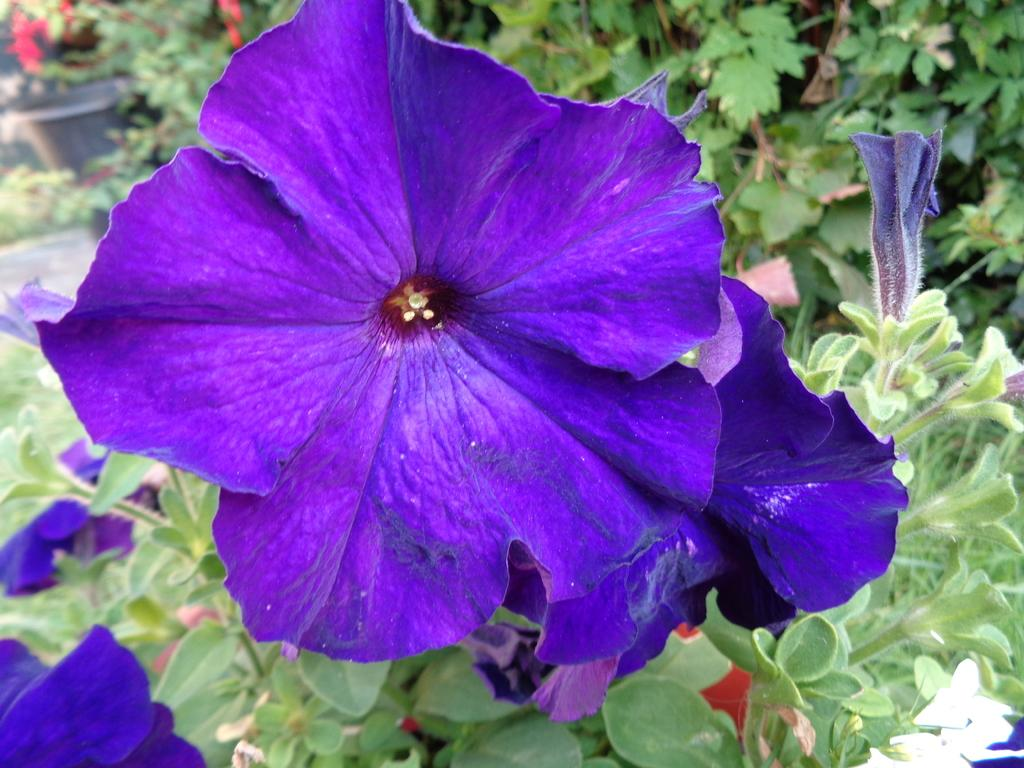What type of living organisms can be seen in the image? Flowers and plants can be seen in the image. Can you describe the plants in the image? The plants in the image are not specified, but they are present alongside the flowers. What type of bushes can be seen in the image? There is no mention of bushes in the image; only flowers and plants are mentioned. Is there a frame around the flowers in the image? There is no reference to a frame in the image; it only features flowers and plants. 